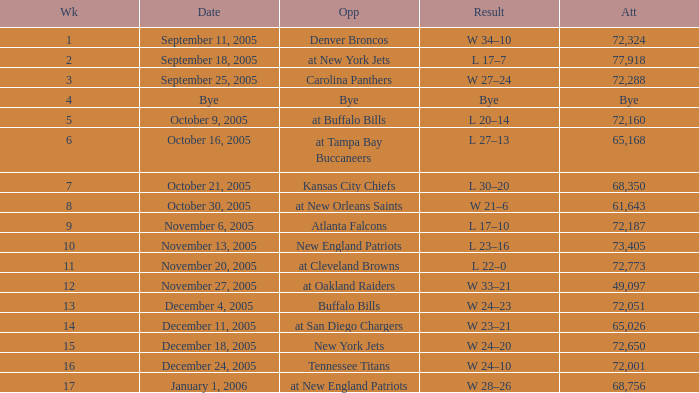Who was the adversary on november 27, 2005? At oakland raiders. 